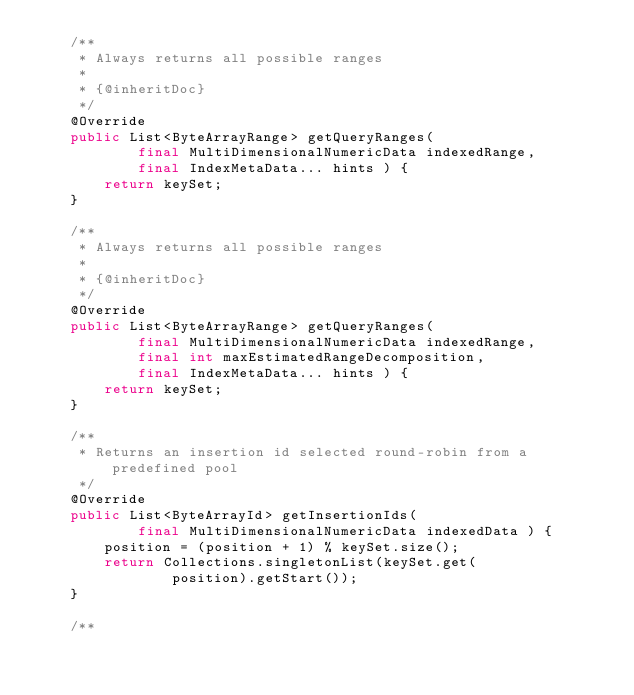<code> <loc_0><loc_0><loc_500><loc_500><_Java_>	/**
	 * Always returns all possible ranges
	 * 
	 * {@inheritDoc}
	 */
	@Override
	public List<ByteArrayRange> getQueryRanges(
			final MultiDimensionalNumericData indexedRange,
			final IndexMetaData... hints ) {
		return keySet;
	}

	/**
	 * Always returns all possible ranges
	 * 
	 * {@inheritDoc}
	 */
	@Override
	public List<ByteArrayRange> getQueryRanges(
			final MultiDimensionalNumericData indexedRange,
			final int maxEstimatedRangeDecomposition,
			final IndexMetaData... hints ) {
		return keySet;
	}

	/**
	 * Returns an insertion id selected round-robin from a predefined pool
	 */
	@Override
	public List<ByteArrayId> getInsertionIds(
			final MultiDimensionalNumericData indexedData ) {
		position = (position + 1) % keySet.size();
		return Collections.singletonList(keySet.get(
				position).getStart());
	}

	/**</code> 